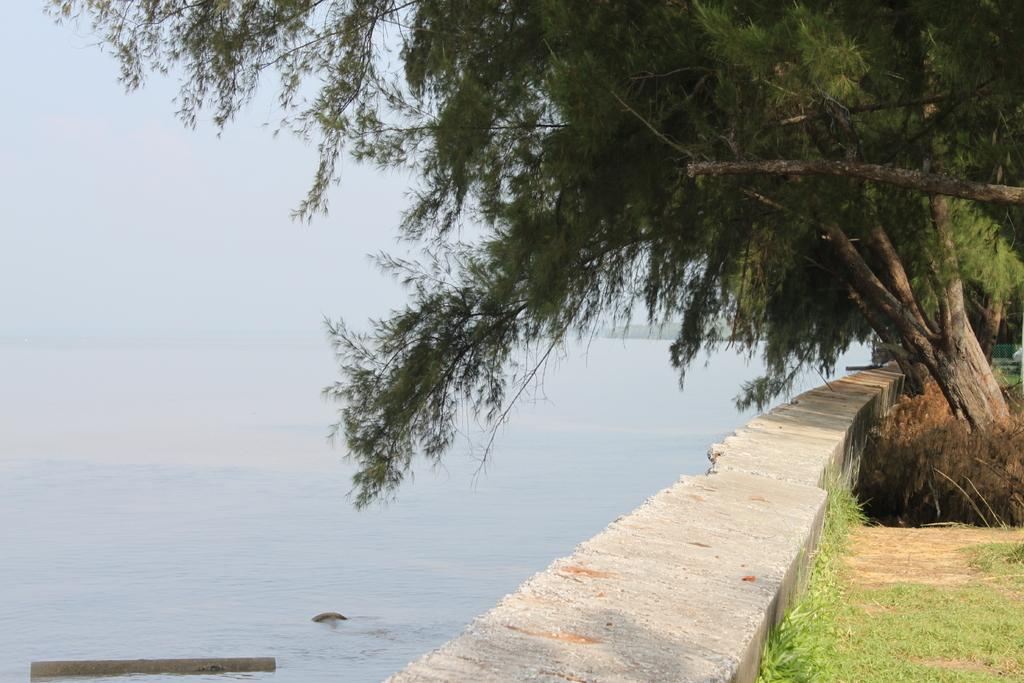What type of vegetation can be seen in the image? There are trees and grass in the image. What is the location of the wall in the image? The wall is on the left side of the image. What can be seen in the image besides vegetation and the wall? There is water and the sky visible in the image. What type of action is the ear performing in the image? There is no ear present in the image, so it cannot perform any action. Does the existence of the image prove the existence of unicorns? The image does not show any unicorns, so it cannot prove their existence. 